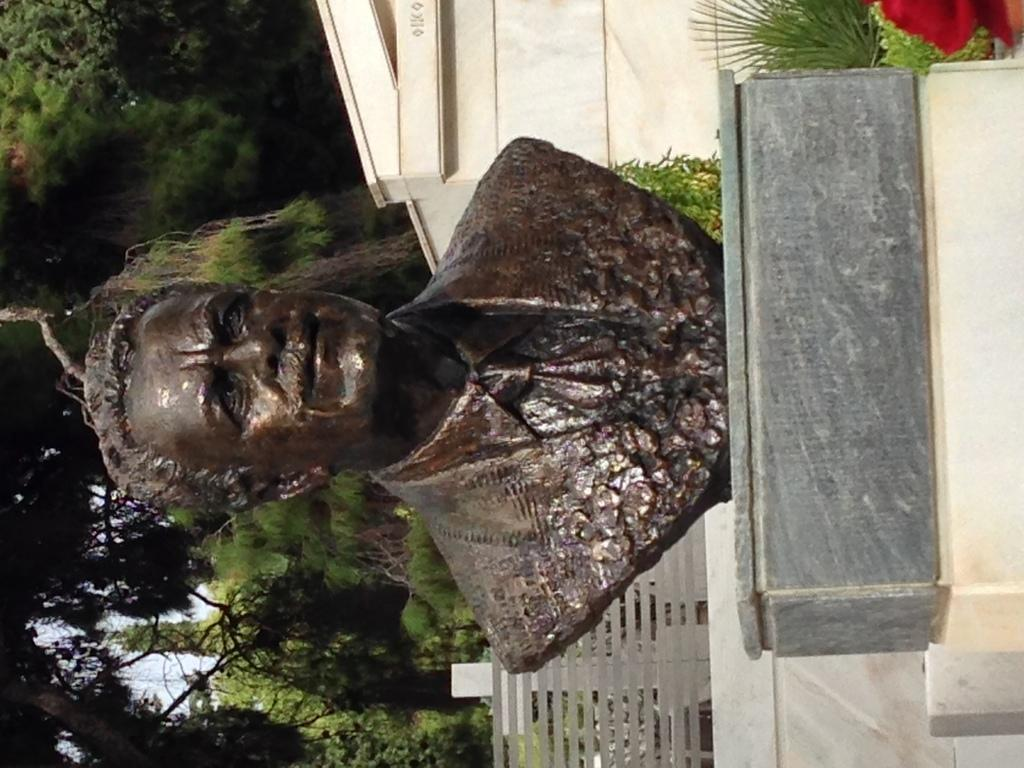What is the main subject of the image? There is a statue in the image. What is the color of the statue? The statue is brown in color. What can be seen in the background of the image? There is a building and trees in the background of the image. What is the color of the building? The building is cream in color. What is the color of the trees? The trees are green in color. How many sheep are visible in the image? There are no sheep present in the image. What type of poison is being used by the writer in the image? There is no writer or poison present in the image. 